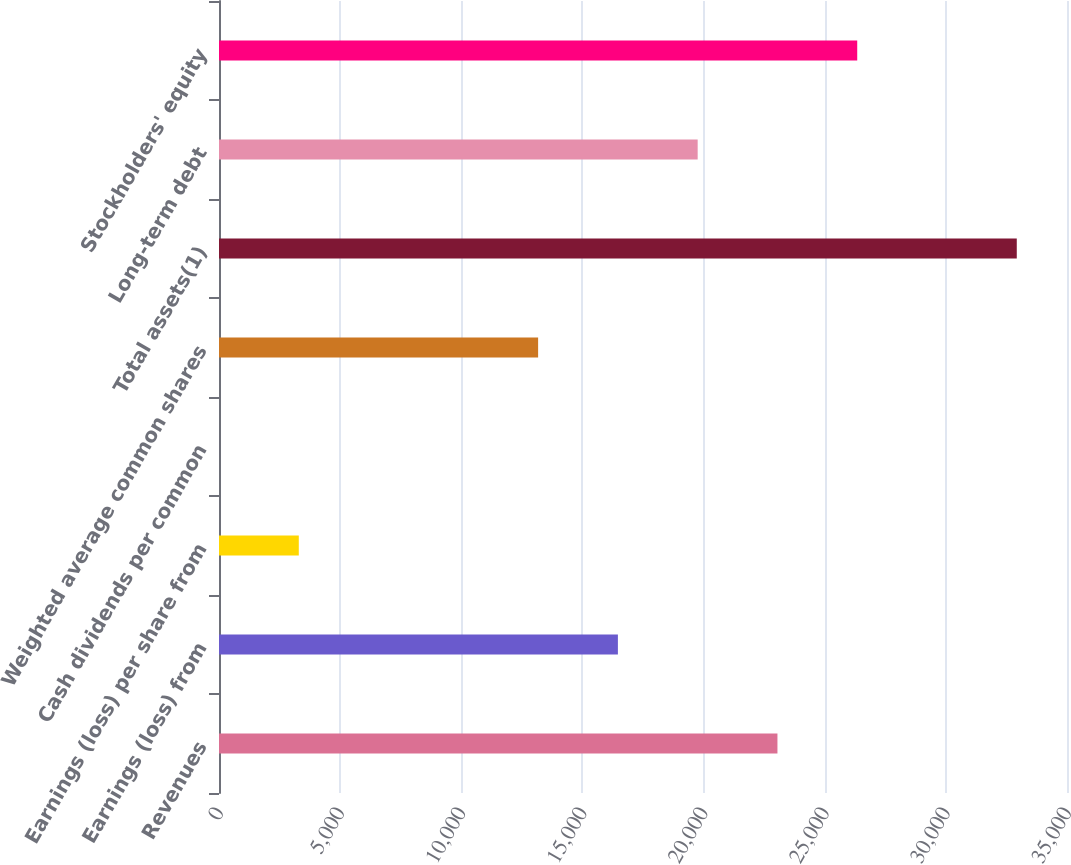Convert chart. <chart><loc_0><loc_0><loc_500><loc_500><bar_chart><fcel>Revenues<fcel>Earnings (loss) from<fcel>Earnings (loss) per share from<fcel>Cash dividends per common<fcel>Weighted average common shares<fcel>Total assets(1)<fcel>Long-term debt<fcel>Stockholders' equity<nl><fcel>23049.1<fcel>16463.8<fcel>3293.28<fcel>0.64<fcel>13171.2<fcel>32927<fcel>19756.5<fcel>26341.8<nl></chart> 